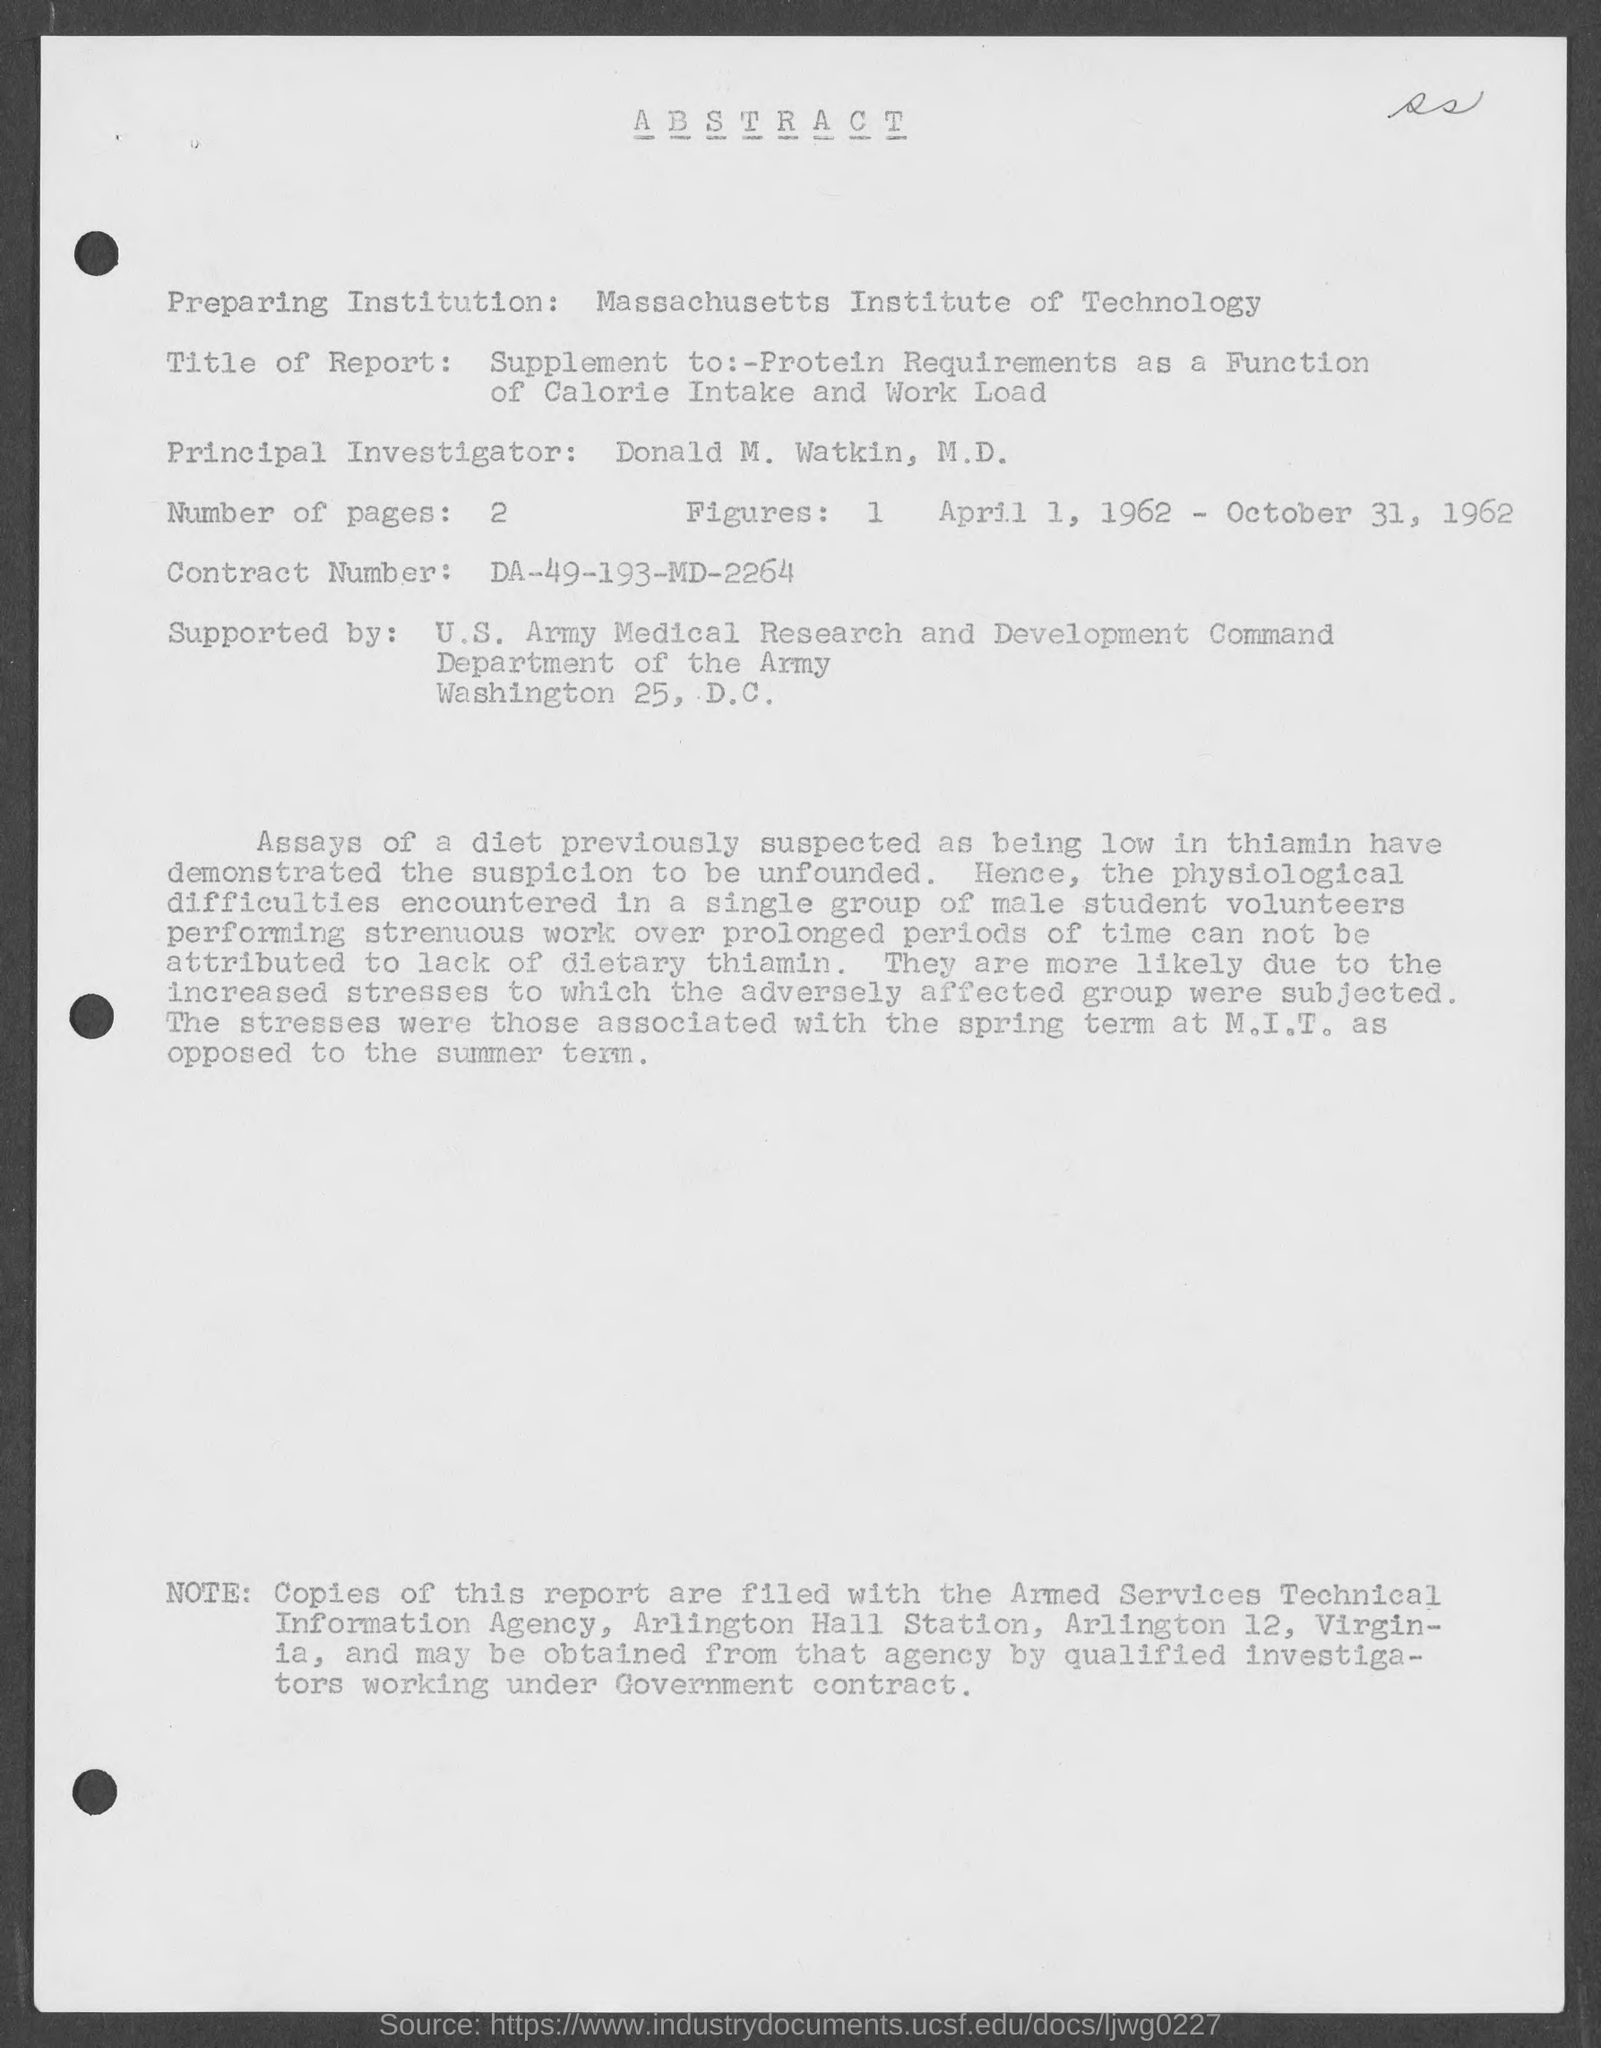What is Preparing Institution?
Your answer should be very brief. Massachusetts Institute of Technology. Who is the Principal Investigator ?
Keep it short and to the point. Donald M. Watkin. How many Number of Pages?
Offer a very short reply. 2. What is the Contract Number ?
Your answer should be compact. DA-49-193-MD-2264. By Whom it is Supported ?
Your response must be concise. U.S. Army Medical Research and Development Command. 